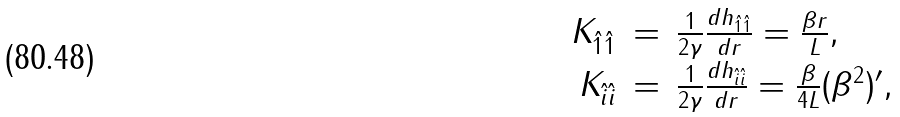Convert formula to latex. <formula><loc_0><loc_0><loc_500><loc_500>\begin{array} { r c l } K _ { \hat { 1 } \hat { 1 } } & = & \frac { 1 } { 2 \gamma } \frac { d h _ { \hat { 1 } \hat { 1 } } } { d r } = \frac { \beta r } { L } , \\ K _ { \hat { i } \hat { i } } & = & \frac { 1 } { 2 \gamma } \frac { d h _ { \hat { i } \hat { i } } } { d r } = \frac { \beta } { 4 L } ( \beta ^ { 2 } ) ^ { \prime } , \\ \end{array}</formula> 